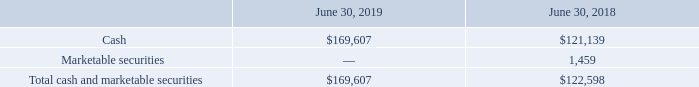Liquidity and Capital Resources
The following summarizes information regarding our cash, investments, and working capital (in thousands):
Cash was $169.6 million at June 30, 2019, representing an increase of $48.5 million from $121.1 million at June 30, 2018. Cash increased primarily due to cash provided by operations of $104.9 million partially offset by cash used in investing activities of $21.8 million mainly for capital expenditures, and cash used in financing activities of $34.4 million mainly as a result of repayments of debt and repurchases of stock.
Cash was $121.1 million at June 30, 2018, representing a decrease of $9.3 million from $130.5 million at June 30, 2017. Cash and cash equivalents decreased primarily due to cash used in investing activities of $132.5 million mainly for the acquisitions of the Campus Fabric and Data Center Businesses and capital expenditures, partially offset by cash provided by financing activities of $104.7 million as a result of additional borrowings for the acquisitions and cash provided by operations of $19.0 million.
Which years does the table provide information for the company's cash, investments, and working capital? 2019, 2018. What was the amount of cash in 2018?
Answer scale should be: thousand. 121,139. What was the Total cash and marketable securities in 2019?
Answer scale should be: thousand. 169,607. How many years did the amount of Cash exceed $100,000 thousand? 2019##2018
Answer: 2. What was marketable securities as a percentage of total cash and marketable securities in 2018?
Answer scale should be: percent. 1,459/122,598
Answer: 1.19. What was the percentage change in Total cash and marketable securities between 2018 and 2019?
Answer scale should be: percent. (169,607-122,598)/122,598
Answer: 38.34. 